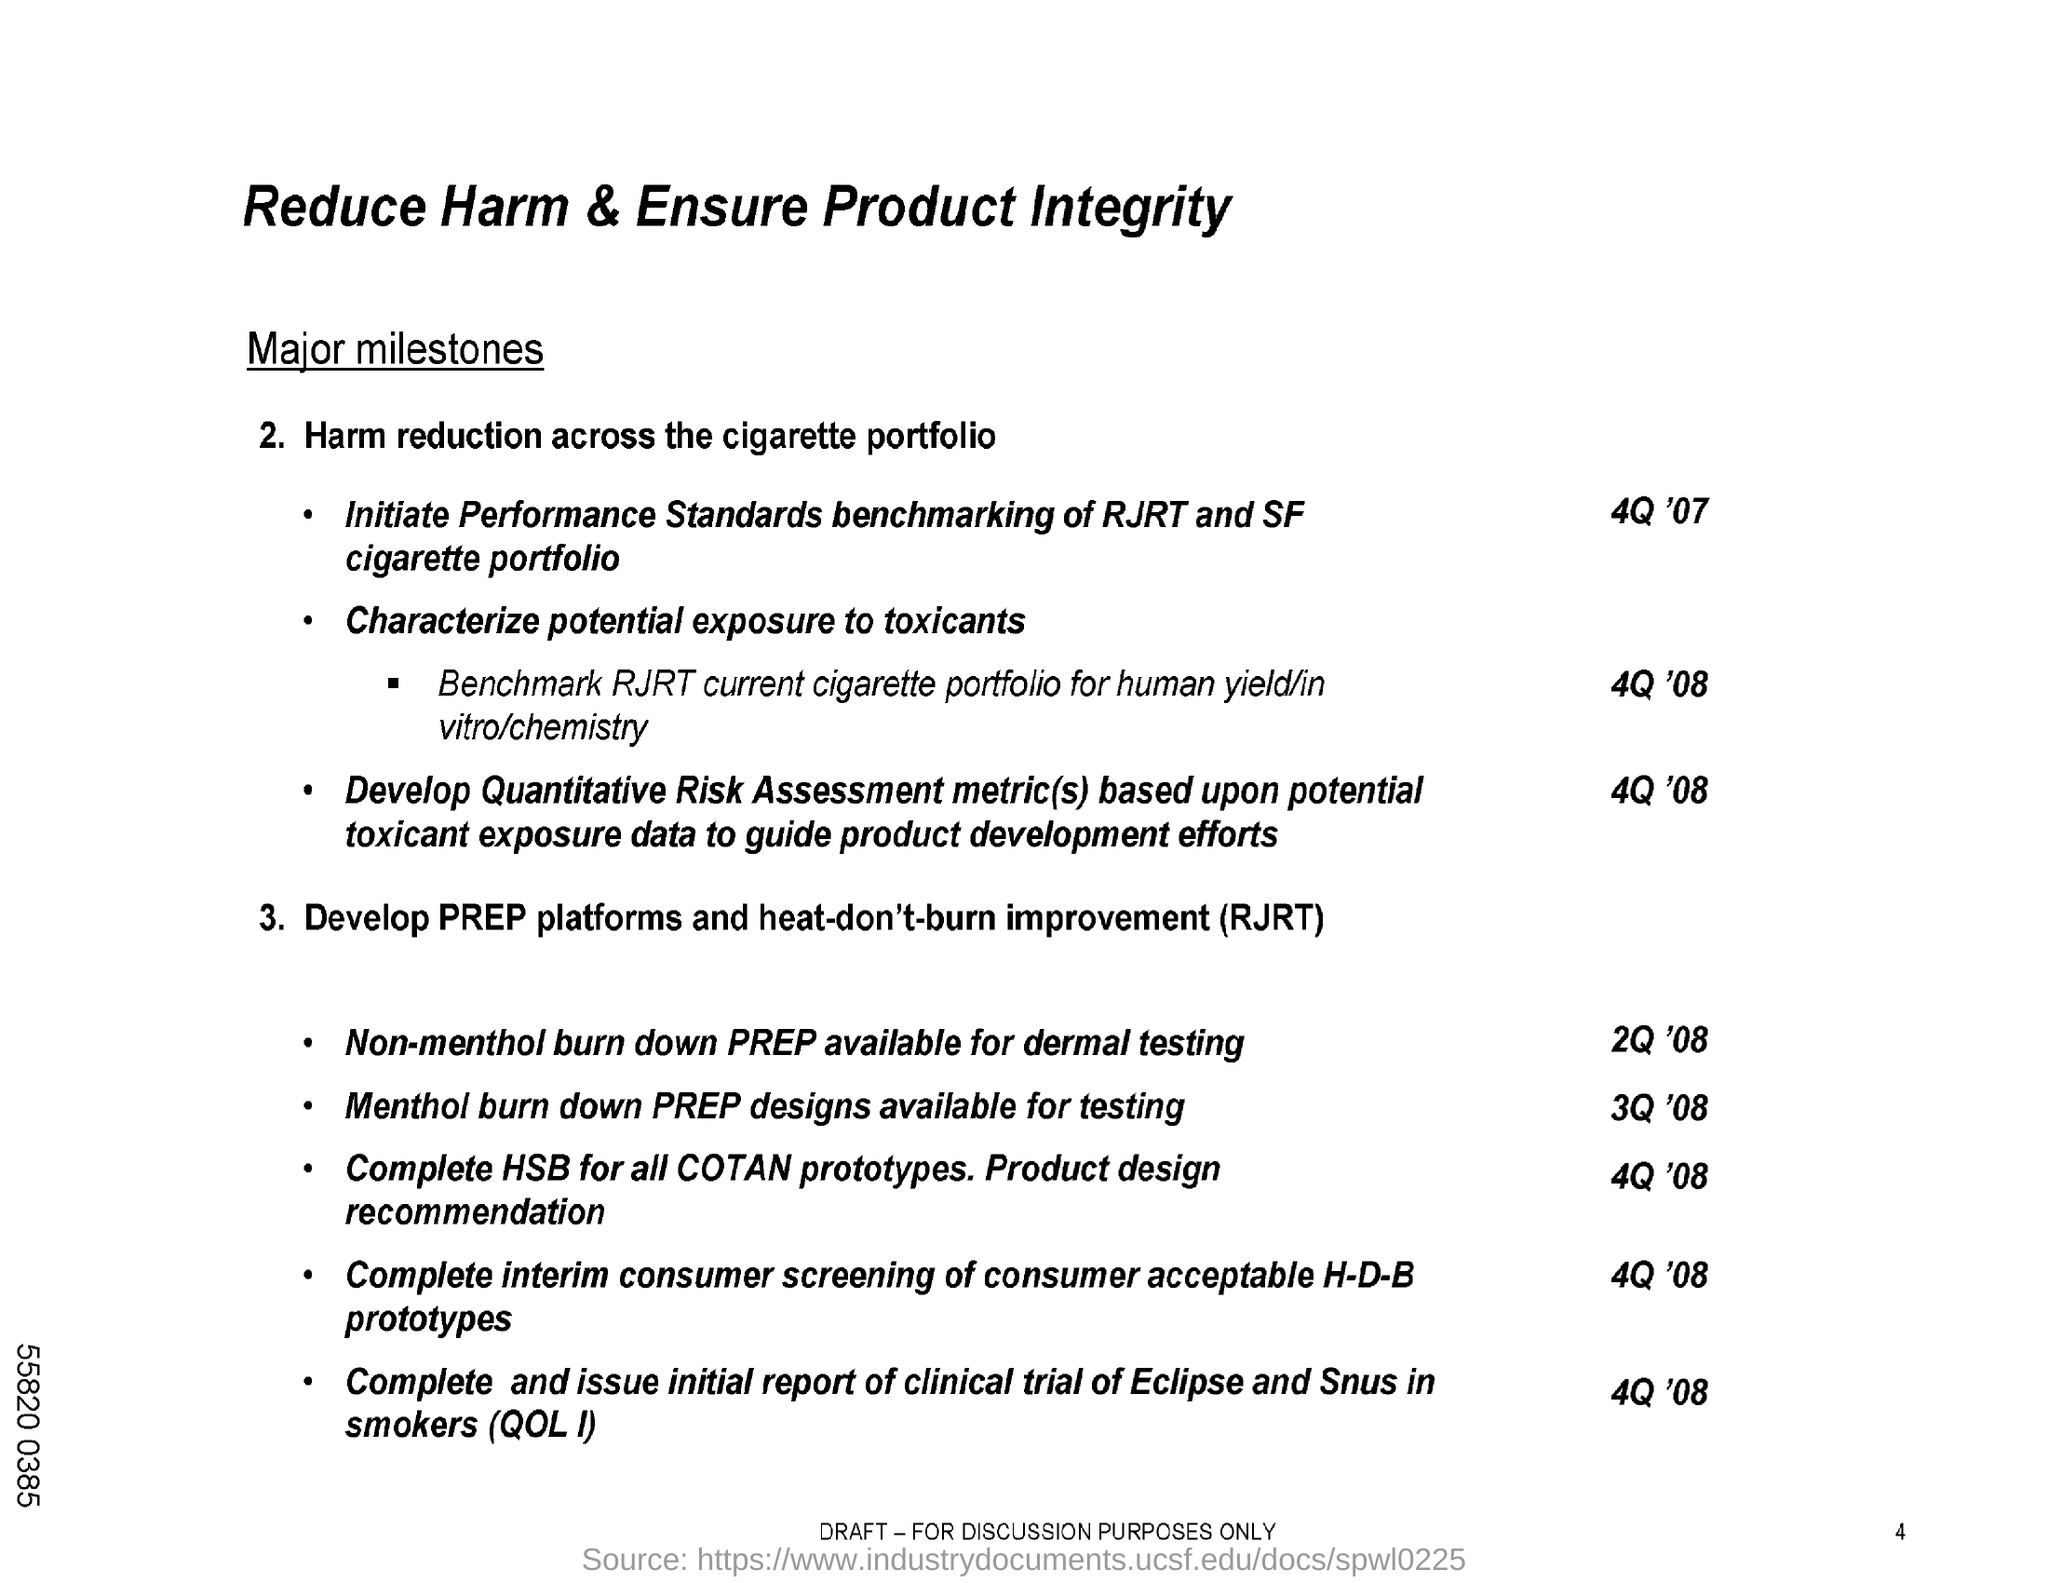What is the title of the document?
Ensure brevity in your answer.  Reduce Harm & Ensure Product Integrity. What is the second title in this document?
Ensure brevity in your answer.  Major milestones. 